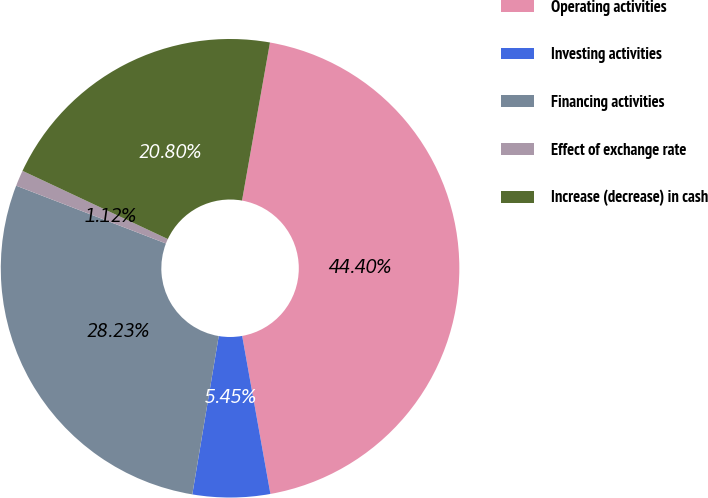<chart> <loc_0><loc_0><loc_500><loc_500><pie_chart><fcel>Operating activities<fcel>Investing activities<fcel>Financing activities<fcel>Effect of exchange rate<fcel>Increase (decrease) in cash<nl><fcel>44.4%<fcel>5.45%<fcel>28.23%<fcel>1.12%<fcel>20.8%<nl></chart> 